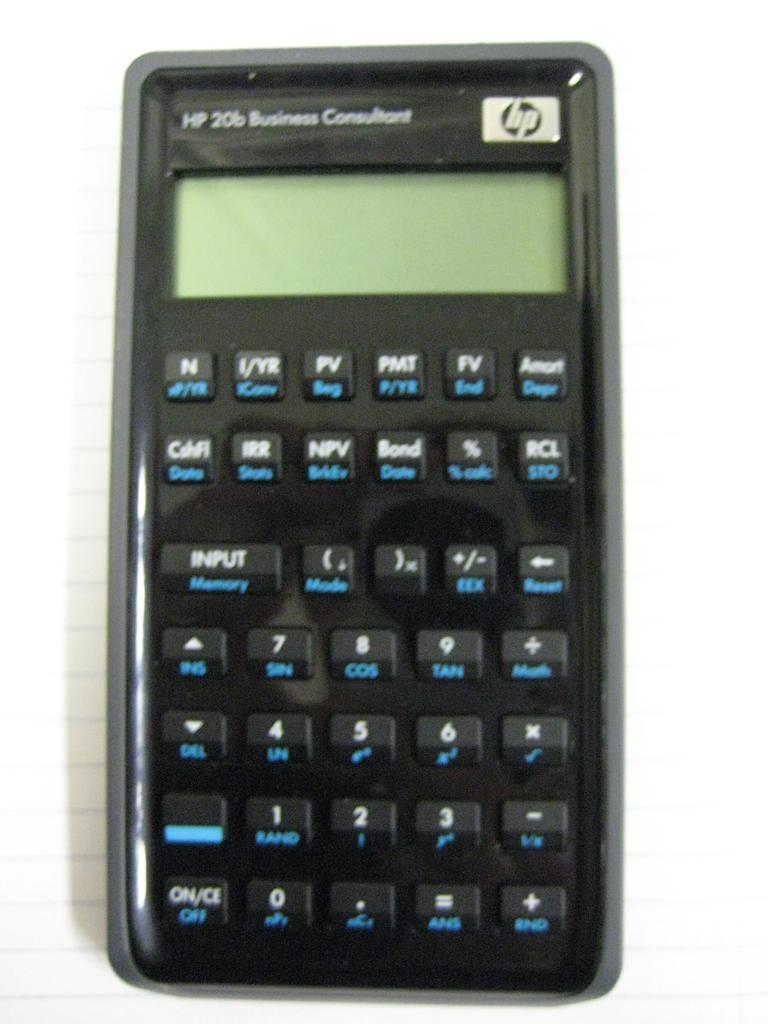Who makes this brand of calculators?
Offer a very short reply. Hp. What is this device called?
Your answer should be very brief. Hp 20b business consultant. 